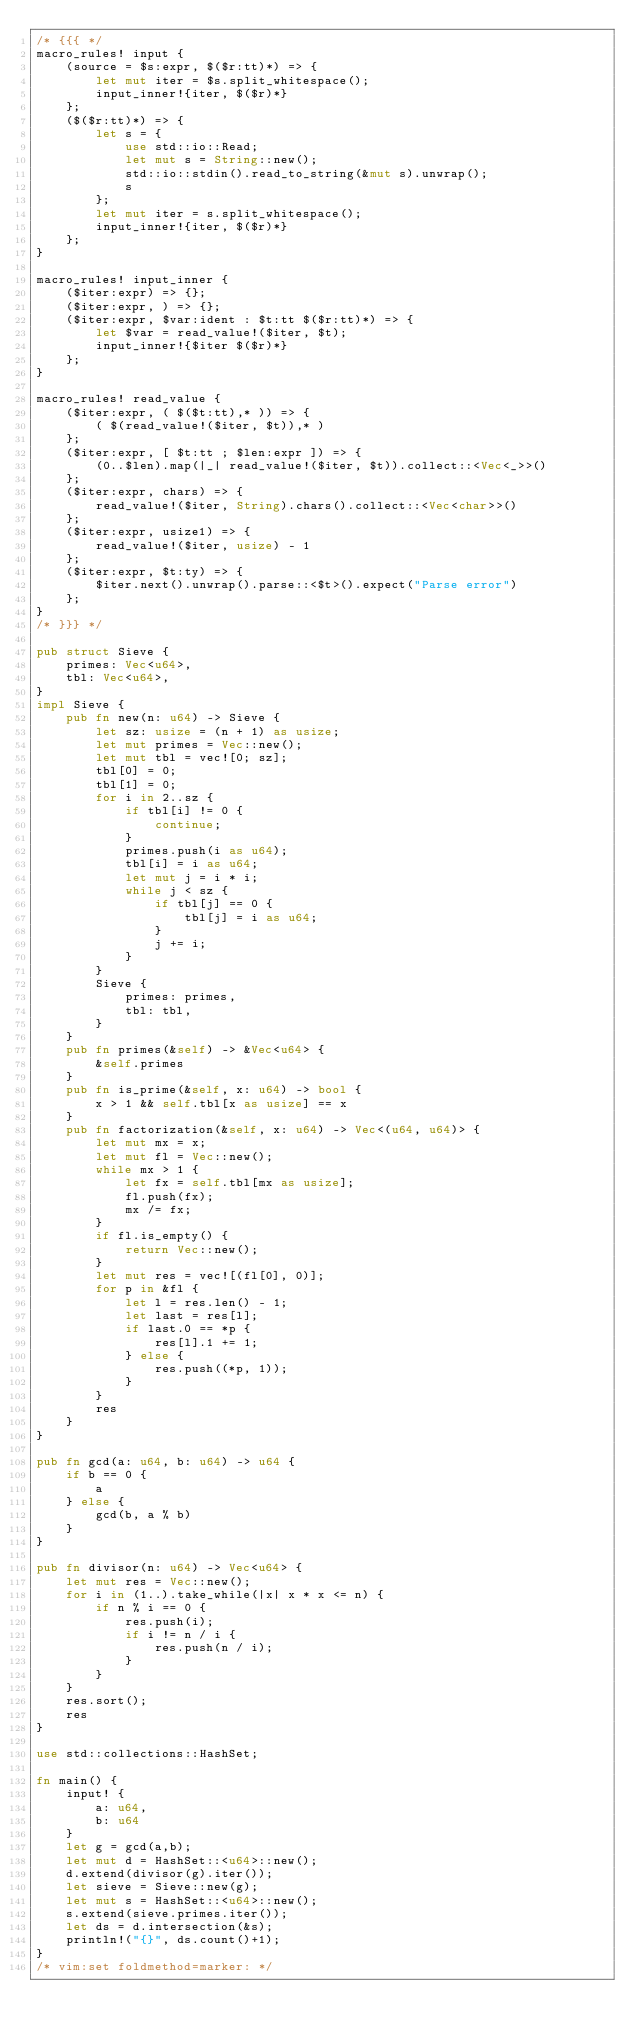Convert code to text. <code><loc_0><loc_0><loc_500><loc_500><_Rust_>/* {{{ */
macro_rules! input {
    (source = $s:expr, $($r:tt)*) => {
        let mut iter = $s.split_whitespace();
        input_inner!{iter, $($r)*}
    };
    ($($r:tt)*) => {
        let s = {
            use std::io::Read;
            let mut s = String::new();
            std::io::stdin().read_to_string(&mut s).unwrap();
            s
        };
        let mut iter = s.split_whitespace();
        input_inner!{iter, $($r)*}
    };
}

macro_rules! input_inner {
    ($iter:expr) => {};
    ($iter:expr, ) => {};
    ($iter:expr, $var:ident : $t:tt $($r:tt)*) => {
        let $var = read_value!($iter, $t);
        input_inner!{$iter $($r)*}
    };
}

macro_rules! read_value {
    ($iter:expr, ( $($t:tt),* )) => {
        ( $(read_value!($iter, $t)),* )
    };
    ($iter:expr, [ $t:tt ; $len:expr ]) => {
        (0..$len).map(|_| read_value!($iter, $t)).collect::<Vec<_>>()
    };
    ($iter:expr, chars) => {
        read_value!($iter, String).chars().collect::<Vec<char>>()
    };
    ($iter:expr, usize1) => {
        read_value!($iter, usize) - 1
    };
    ($iter:expr, $t:ty) => {
        $iter.next().unwrap().parse::<$t>().expect("Parse error")
    };
}
/* }}} */

pub struct Sieve {
    primes: Vec<u64>,
    tbl: Vec<u64>,
}
impl Sieve {
    pub fn new(n: u64) -> Sieve {
        let sz: usize = (n + 1) as usize;
        let mut primes = Vec::new();
        let mut tbl = vec![0; sz];
        tbl[0] = 0;
        tbl[1] = 0;
        for i in 2..sz {
            if tbl[i] != 0 {
                continue;
            }
            primes.push(i as u64);
            tbl[i] = i as u64;
            let mut j = i * i;
            while j < sz {
                if tbl[j] == 0 {
                    tbl[j] = i as u64;
                }
                j += i;
            }
        }
        Sieve {
            primes: primes,
            tbl: tbl,
        }
    }
    pub fn primes(&self) -> &Vec<u64> {
        &self.primes
    }
    pub fn is_prime(&self, x: u64) -> bool {
        x > 1 && self.tbl[x as usize] == x
    }
    pub fn factorization(&self, x: u64) -> Vec<(u64, u64)> {
        let mut mx = x;
        let mut fl = Vec::new();
        while mx > 1 {
            let fx = self.tbl[mx as usize];
            fl.push(fx);
            mx /= fx;
        }
        if fl.is_empty() {
            return Vec::new();
        }
        let mut res = vec![(fl[0], 0)];
        for p in &fl {
            let l = res.len() - 1;
            let last = res[l];
            if last.0 == *p {
                res[l].1 += 1;
            } else {
                res.push((*p, 1));
            }
        }
        res
    }
}

pub fn gcd(a: u64, b: u64) -> u64 {
    if b == 0 {
        a
    } else {
        gcd(b, a % b)
    }
}

pub fn divisor(n: u64) -> Vec<u64> {
    let mut res = Vec::new();
    for i in (1..).take_while(|x| x * x <= n) {
        if n % i == 0 {
            res.push(i);
            if i != n / i {
                res.push(n / i);
            }
        }
    }
    res.sort();
    res
}

use std::collections::HashSet;

fn main() {
    input! {
        a: u64,
        b: u64
    }
    let g = gcd(a,b);
    let mut d = HashSet::<u64>::new();
    d.extend(divisor(g).iter());
    let sieve = Sieve::new(g);
    let mut s = HashSet::<u64>::new();
    s.extend(sieve.primes.iter());
    let ds = d.intersection(&s);
    println!("{}", ds.count()+1);
}
/* vim:set foldmethod=marker: */
</code> 